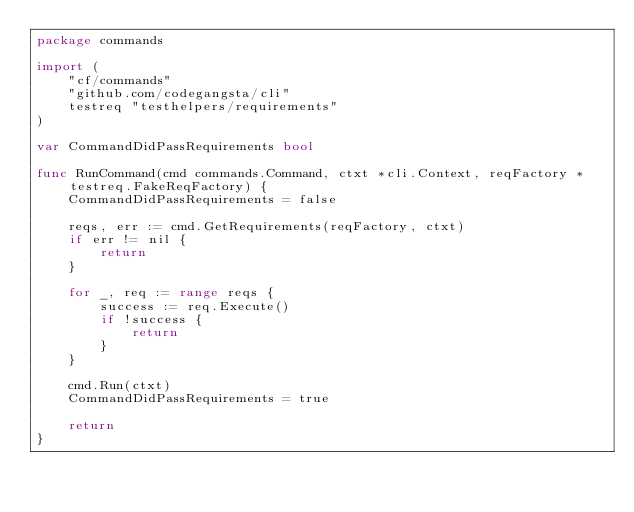<code> <loc_0><loc_0><loc_500><loc_500><_Go_>package commands

import (
	"cf/commands"
	"github.com/codegangsta/cli"
	testreq "testhelpers/requirements"
)

var CommandDidPassRequirements bool

func RunCommand(cmd commands.Command, ctxt *cli.Context, reqFactory *testreq.FakeReqFactory) {
	CommandDidPassRequirements = false

	reqs, err := cmd.GetRequirements(reqFactory, ctxt)
	if err != nil {
		return
	}

	for _, req := range reqs {
		success := req.Execute()
		if !success {
			return
		}
	}

	cmd.Run(ctxt)
	CommandDidPassRequirements = true

	return
}
</code> 